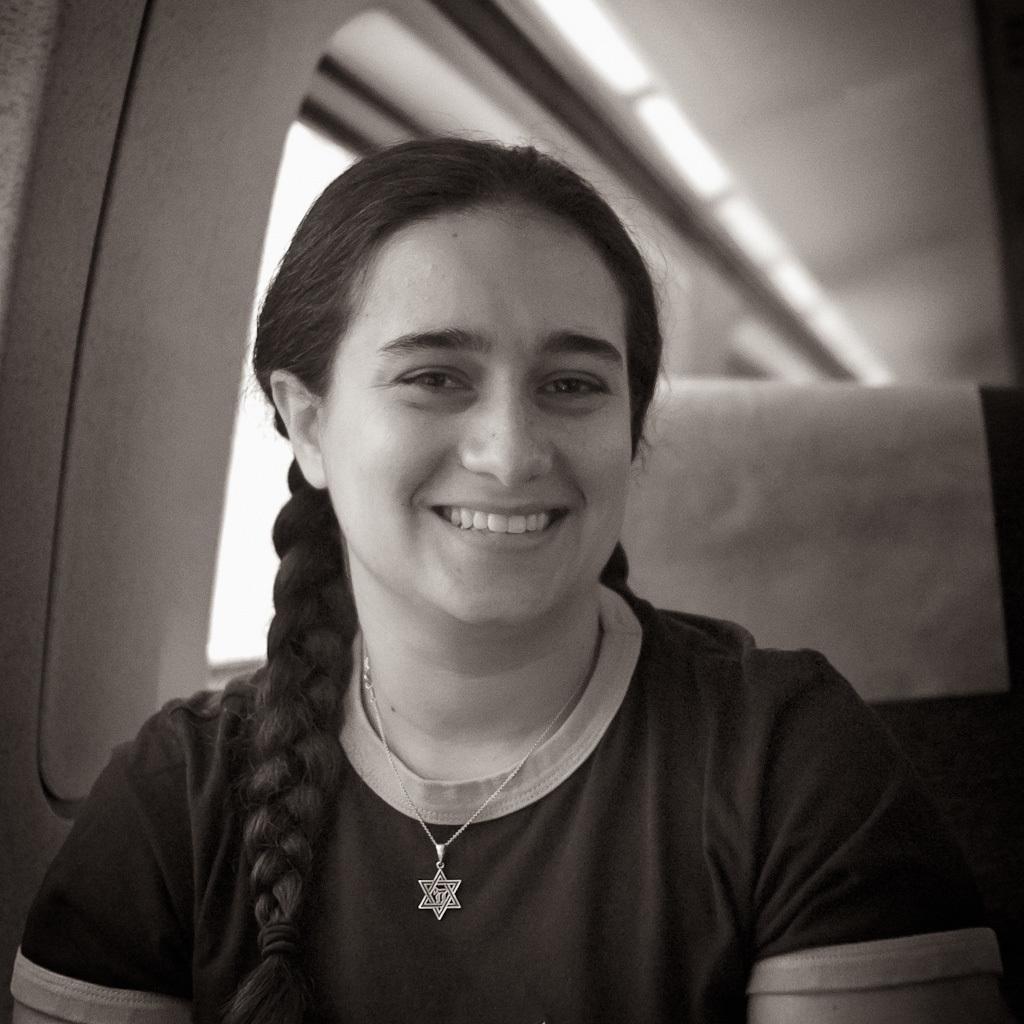How would you summarize this image in a sentence or two? In the foreground I can see a woman is having a smile on her face. In the background I can see a window. It looks as if the image is taken in a vehicle. 